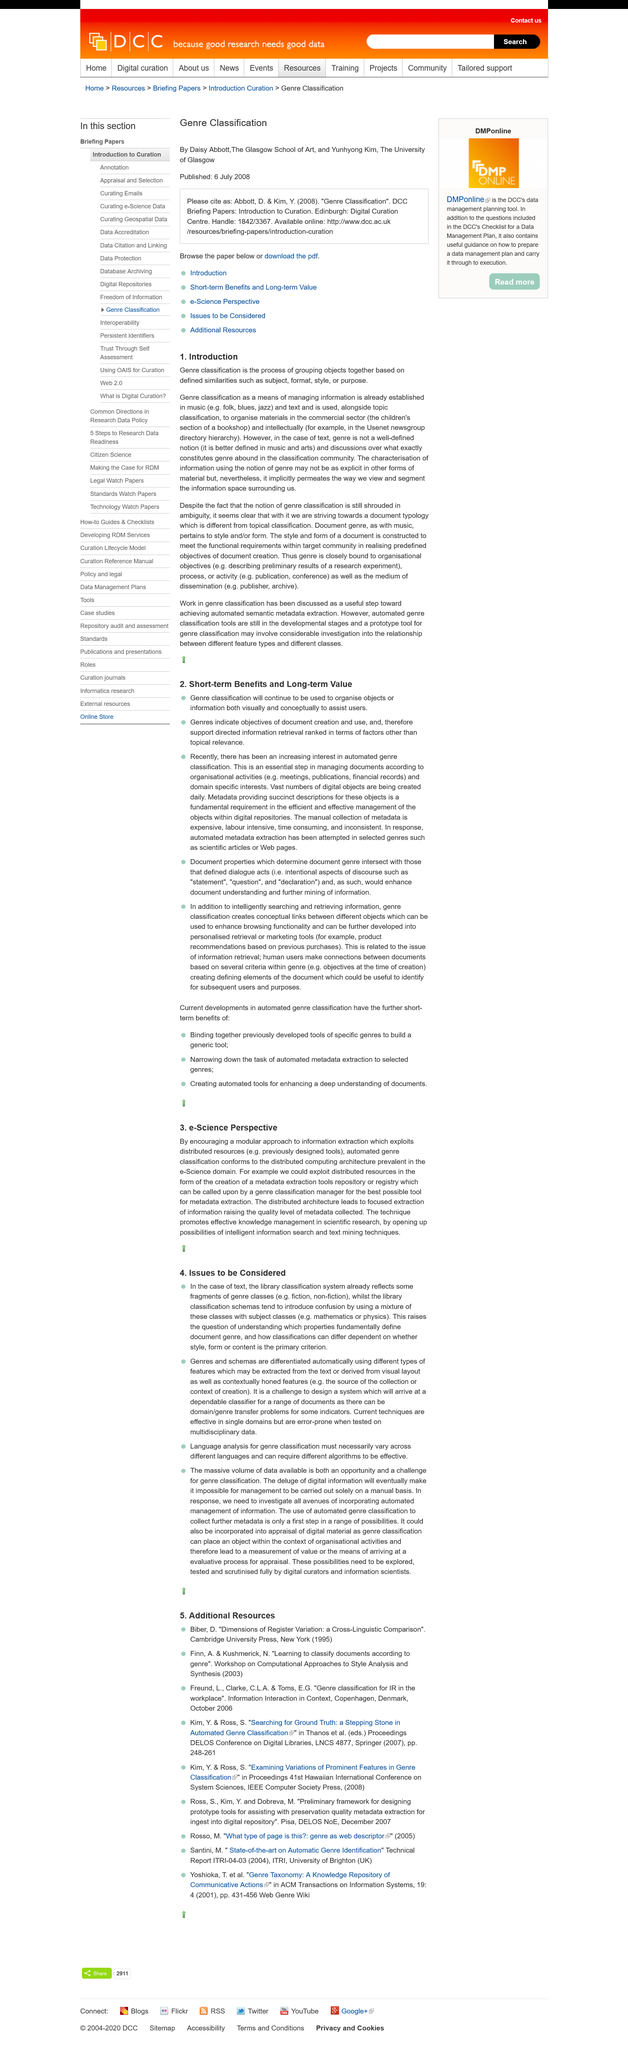Indicate a few pertinent items in this graphic. The introduction discusses genre classification. Subject and format are examples of defined similarities used for grouping objects in genre classification. Genre classification is an established means of managing information in music. 